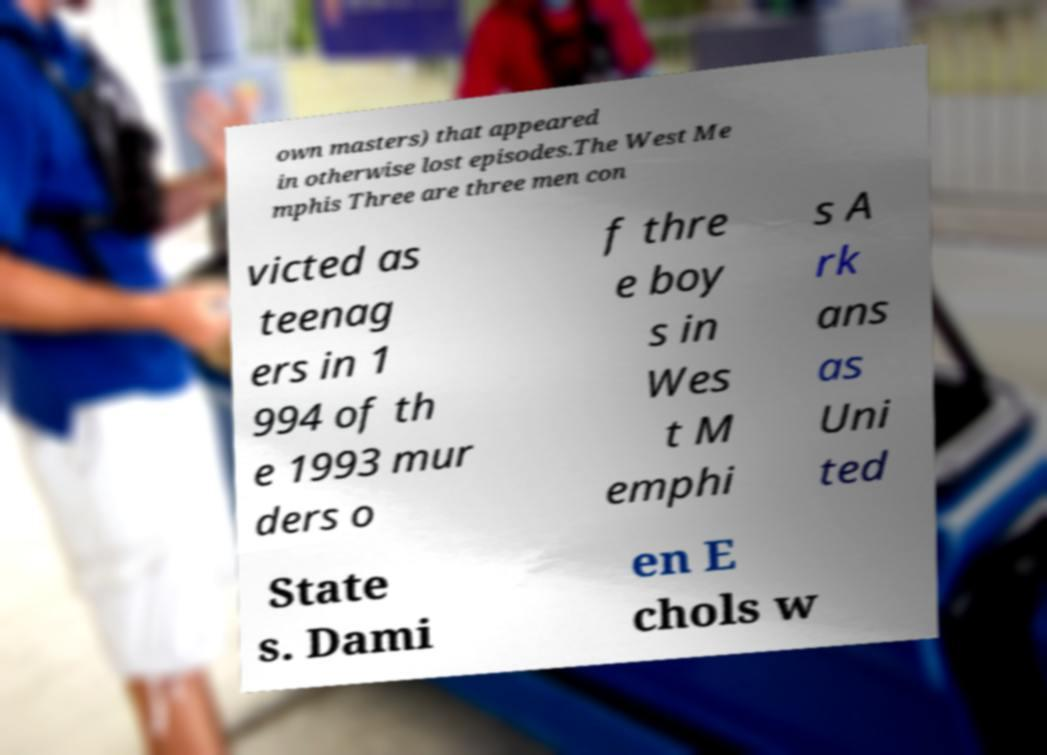What messages or text are displayed in this image? I need them in a readable, typed format. own masters) that appeared in otherwise lost episodes.The West Me mphis Three are three men con victed as teenag ers in 1 994 of th e 1993 mur ders o f thre e boy s in Wes t M emphi s A rk ans as Uni ted State s. Dami en E chols w 